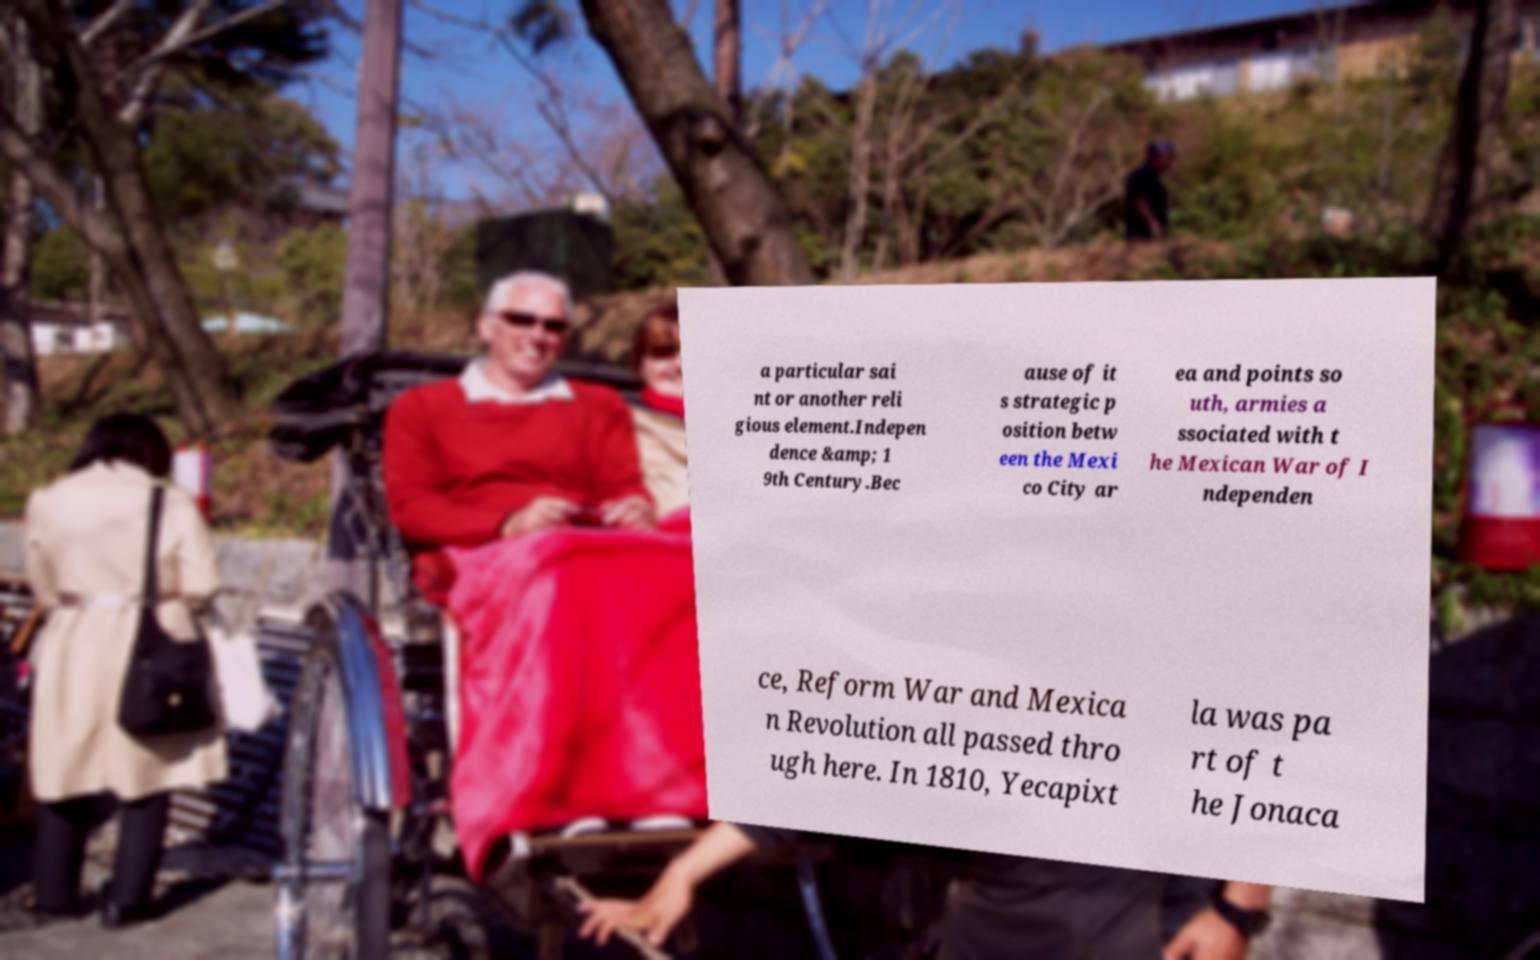Could you assist in decoding the text presented in this image and type it out clearly? a particular sai nt or another reli gious element.Indepen dence &amp; 1 9th Century.Bec ause of it s strategic p osition betw een the Mexi co City ar ea and points so uth, armies a ssociated with t he Mexican War of I ndependen ce, Reform War and Mexica n Revolution all passed thro ugh here. In 1810, Yecapixt la was pa rt of t he Jonaca 